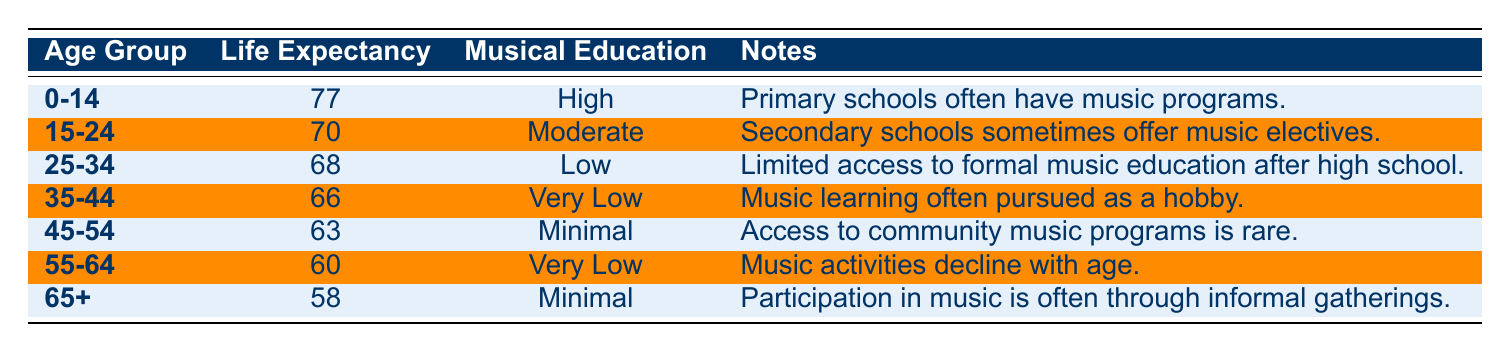What is the life expectancy for the age group 0-14? The table shows that for the age group 0-14, the life expectancy is listed as 77 years.
Answer: 77 How many age groups have a musical education access level labeled as "Low"? According to the table, there is one age group (25-34) that has "Low" access to musical education.
Answer: 1 Is musical education access for the 35-44 age group very low? Yes, the table indicates that the musical education access for the 35-44 age group is labeled as "Very Low".
Answer: Yes What is the average life expectancy for the age groups 45-54 and 55-64? The life expectancies for these age groups are 63 years (45-54) and 60 years (55-64). To find the average, add them together (63 + 60 = 123) and divide by 2. The average life expectancy is 123 / 2 = 61.5.
Answer: 61.5 How does access to musical education change as age increases from 0-14 to 65+? As age increases, access to musical education decreases. The 0-14 age group has "High" access, while the 65+ age group has "Minimal" access, showing a clear decline across the age groups.
Answer: Decreases from High to Minimal Are there any age groups with "Minimal" access to musical education? Yes, both the 45-54 and 65+ age groups have "Minimal" access to musical education according to the table.
Answer: Yes What is the difference in life expectancy between the 25-34 and 45-54 age groups? The life expectancy for the 25-34 age group is 68 years, and for the 45-54 age group, it is 63 years. The difference is calculated as 68 - 63 = 5 years.
Answer: 5 